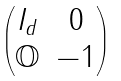Convert formula to latex. <formula><loc_0><loc_0><loc_500><loc_500>\begin{pmatrix} I _ { d } & 0 \\ \mathbb { O } & - 1 \end{pmatrix}</formula> 